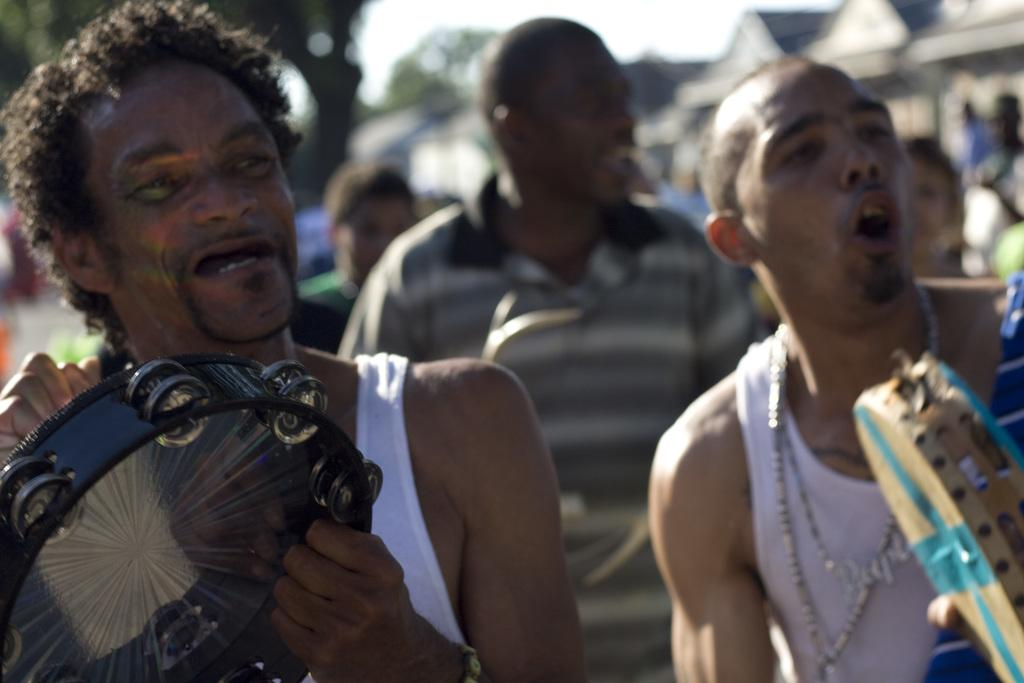How many people are in the image? There are three persons in the image. What are the persons wearing? The persons are wearing clothes. Can you describe the position of the person on the left side of the image? The person on the left side is holding a musical instrument. What can be said about the background of the image? The background of the image is blurred. What type of pencil is the person on the right side of the image using? There is no person on the right side of the image, and no pencil is present in the image. 